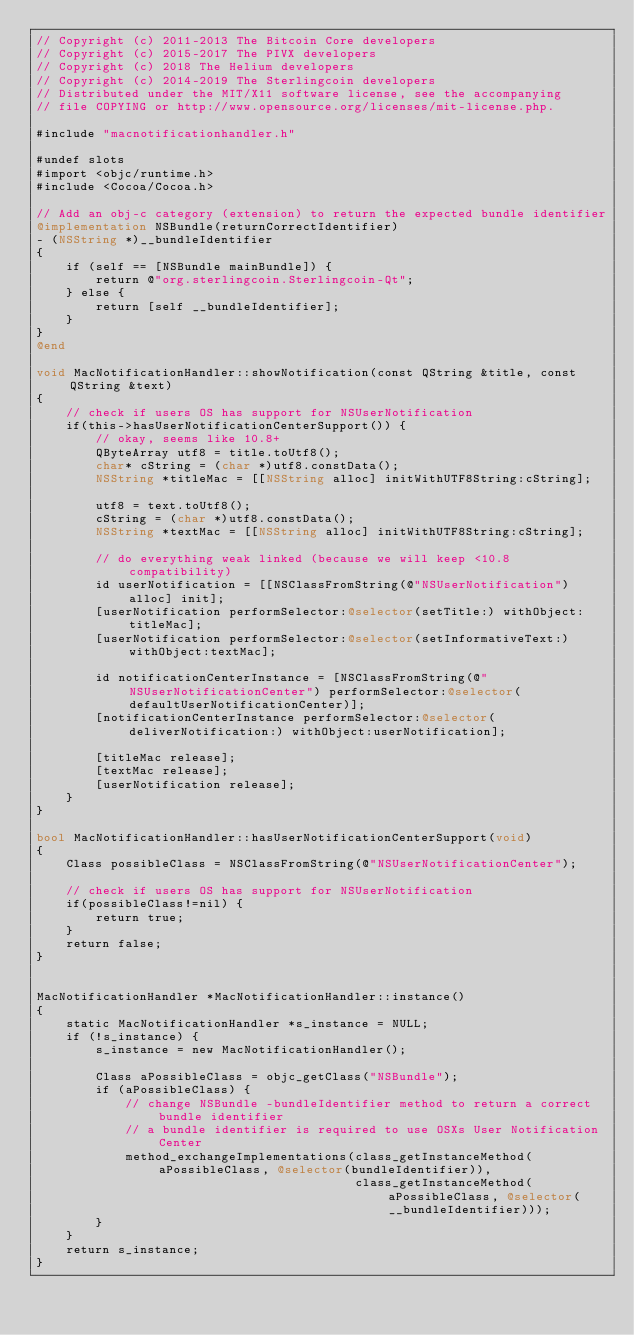<code> <loc_0><loc_0><loc_500><loc_500><_ObjectiveC_>// Copyright (c) 2011-2013 The Bitcoin Core developers
// Copyright (c) 2015-2017 The PIVX developers
// Copyright (c) 2018 The Helium developers
// Copyright (c) 2014-2019 The Sterlingcoin developers
// Distributed under the MIT/X11 software license, see the accompanying
// file COPYING or http://www.opensource.org/licenses/mit-license.php.

#include "macnotificationhandler.h"

#undef slots
#import <objc/runtime.h>
#include <Cocoa/Cocoa.h>

// Add an obj-c category (extension) to return the expected bundle identifier
@implementation NSBundle(returnCorrectIdentifier)
- (NSString *)__bundleIdentifier
{
    if (self == [NSBundle mainBundle]) {
        return @"org.sterlingcoin.Sterlingcoin-Qt";
    } else {
        return [self __bundleIdentifier];
    }
}
@end

void MacNotificationHandler::showNotification(const QString &title, const QString &text)
{
    // check if users OS has support for NSUserNotification
    if(this->hasUserNotificationCenterSupport()) {
        // okay, seems like 10.8+
        QByteArray utf8 = title.toUtf8();
        char* cString = (char *)utf8.constData();
        NSString *titleMac = [[NSString alloc] initWithUTF8String:cString];

        utf8 = text.toUtf8();
        cString = (char *)utf8.constData();
        NSString *textMac = [[NSString alloc] initWithUTF8String:cString];

        // do everything weak linked (because we will keep <10.8 compatibility)
        id userNotification = [[NSClassFromString(@"NSUserNotification") alloc] init];
        [userNotification performSelector:@selector(setTitle:) withObject:titleMac];
        [userNotification performSelector:@selector(setInformativeText:) withObject:textMac];

        id notificationCenterInstance = [NSClassFromString(@"NSUserNotificationCenter") performSelector:@selector(defaultUserNotificationCenter)];
        [notificationCenterInstance performSelector:@selector(deliverNotification:) withObject:userNotification];

        [titleMac release];
        [textMac release];
        [userNotification release];
    }
}

bool MacNotificationHandler::hasUserNotificationCenterSupport(void)
{
    Class possibleClass = NSClassFromString(@"NSUserNotificationCenter");

    // check if users OS has support for NSUserNotification
    if(possibleClass!=nil) {
        return true;
    }
    return false;
}


MacNotificationHandler *MacNotificationHandler::instance()
{
    static MacNotificationHandler *s_instance = NULL;
    if (!s_instance) {
        s_instance = new MacNotificationHandler();
        
        Class aPossibleClass = objc_getClass("NSBundle");
        if (aPossibleClass) {
            // change NSBundle -bundleIdentifier method to return a correct bundle identifier
            // a bundle identifier is required to use OSXs User Notification Center
            method_exchangeImplementations(class_getInstanceMethod(aPossibleClass, @selector(bundleIdentifier)),
                                           class_getInstanceMethod(aPossibleClass, @selector(__bundleIdentifier)));
        }
    }
    return s_instance;
}
</code> 